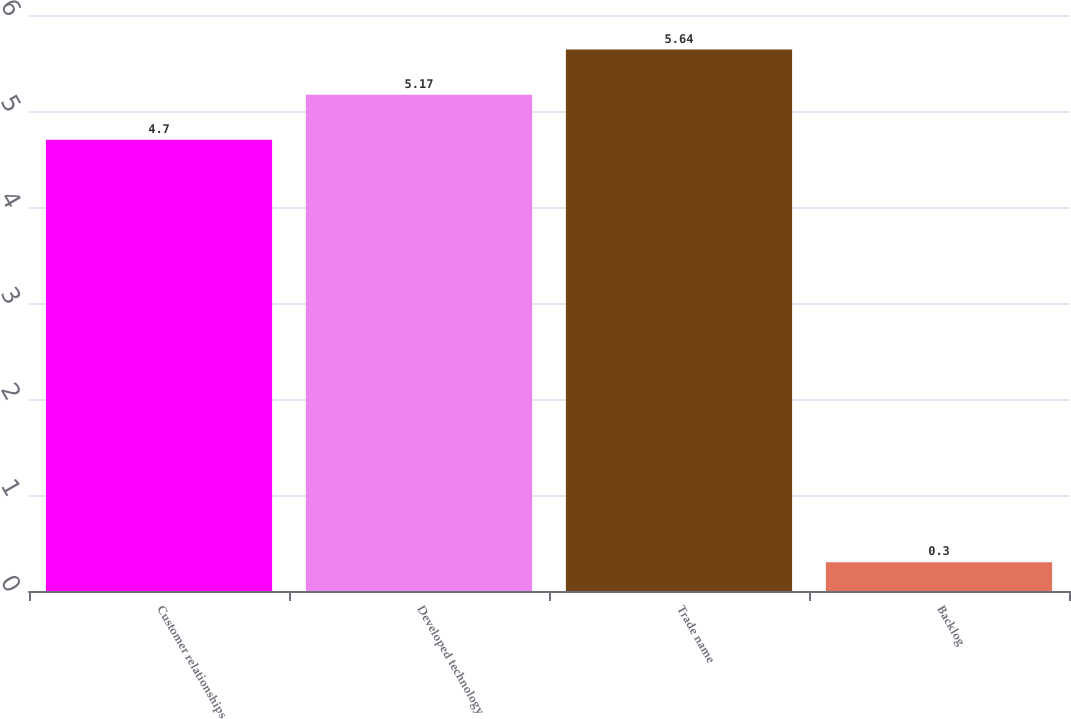Convert chart. <chart><loc_0><loc_0><loc_500><loc_500><bar_chart><fcel>Customer relationships<fcel>Developed technology<fcel>Trade name<fcel>Backlog<nl><fcel>4.7<fcel>5.17<fcel>5.64<fcel>0.3<nl></chart> 